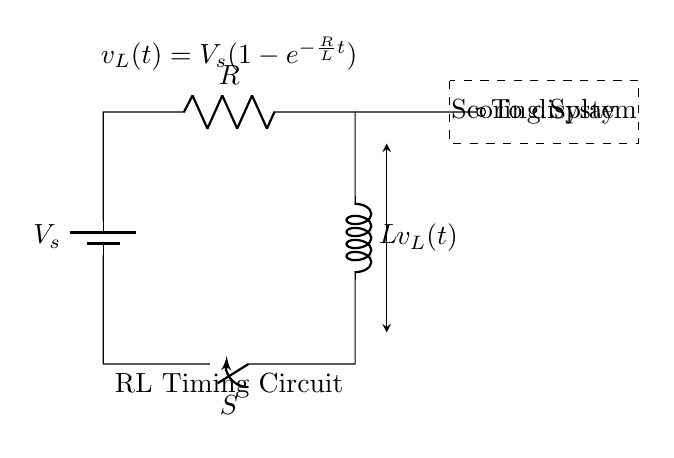What is the power source in the circuit? The power source is represented by the battery symbol which indicates a voltage supply, labeled as \( V_s \).
Answer: Voltage source What do the letters R and L represent in this circuit? In this circuit diagram, R represents the resistor and L represents the inductor, which are the two main components of the RL circuit.
Answer: Resistor and Inductor What is the expression for the voltage across the inductor? The voltage across the inductor is given by the equation \( v_L(t) = V_s(1 - e^{-\frac{R}{L}t}) \), indicating how the voltage changes over time when connected to the circuit.
Answer: V_s(1 - e^{-\frac{R}{L}t}) What happens when the switch is closed (S)? Closing the switch connects the power source to the RL circuit, allowing current to flow and initiating the charging process of the inductor, leading to a gradual increase in the voltage across it.
Answer: Current flows How does the resistor affect the timing of the circuit? The resistor value (R) influences the time constant of the RL circuit, which is calculated as \( \tau = \frac{L}{R} \). A higher resistance results in a slower rise time for the voltage across the inductor.
Answer: Increases timing What is the significance of the dashed rectangle labeled "Scoring System"? The dashed rectangle signifies a functional component of the circuit where the voltage across the inductor is sent to, functioning as the scoring display system for gymnastics, indicating performance based on timing.
Answer: Scoring display What does the notation \( e^{-\frac{R}{L}t} \) signify? The notation represents the exponential decay factor in the voltage function, illustrating how the inductor’s voltage approaches the source voltage over time with continuing current flow in the circuit.
Answer: Exponential decay 